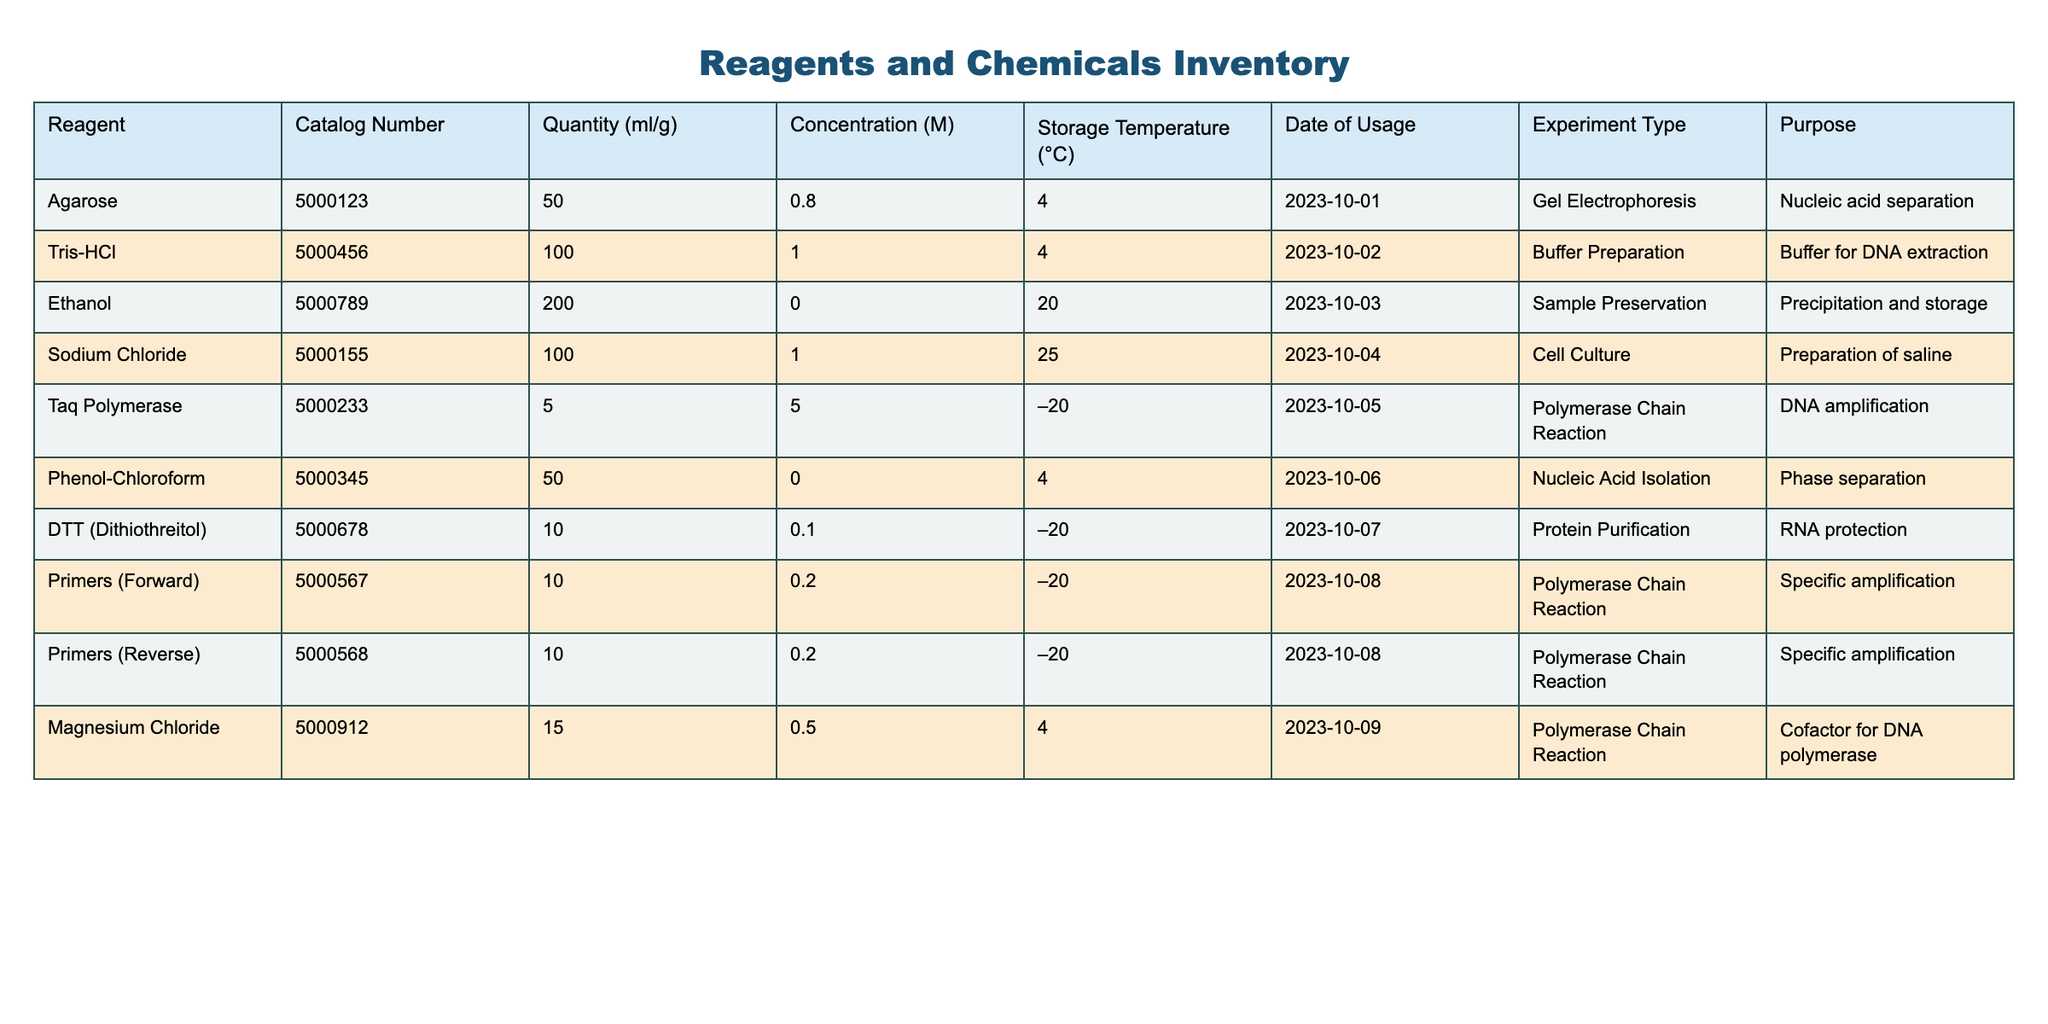What is the storage temperature for Taq Polymerase? The storage temperature for Taq Polymerase is –20°C, which can be found in the 'Storage Temperature (°C)' column next to Taq Polymerase in the table.
Answer: –20°C How much Agarose was used for Gel Electrophoresis? The table states that 50 ml of Agarose was used, as indicated in the 'Quantity (ml/g)' column next to Agarose in the 'Experiment Type' section for Gel Electrophoresis.
Answer: 50 ml Is there any reagent used in Polymerase Chain Reaction stored at room temperature? No, all reagents used in Polymerase Chain Reaction, including Taq Polymerase, Magnesium Chloride, and Primers, are stored at either –20°C or 4°C, as indicated in the 'Storage Temperature (°C)' column.
Answer: No What is the total quantity of ethanol used compared to Sodium Chloride? The total quantity of Ethanol (200 ml) can be compared to Sodium Chloride (100 ml). So, Ethanol is twice the quantity of Sodium Chloride, calculated as 200 ml - 100 ml = 100 ml difference.
Answer: 200 ml (Ethanol), 100 ml (Sodium Chloride) What percentage of the total reagents used were for Polymerase Chain Reaction? There are 3 reagents listed for Polymerase Chain Reaction out of a total of 10 reagents. Therefore, the percentage is (3/10)*100 = 30%.
Answer: 30% 